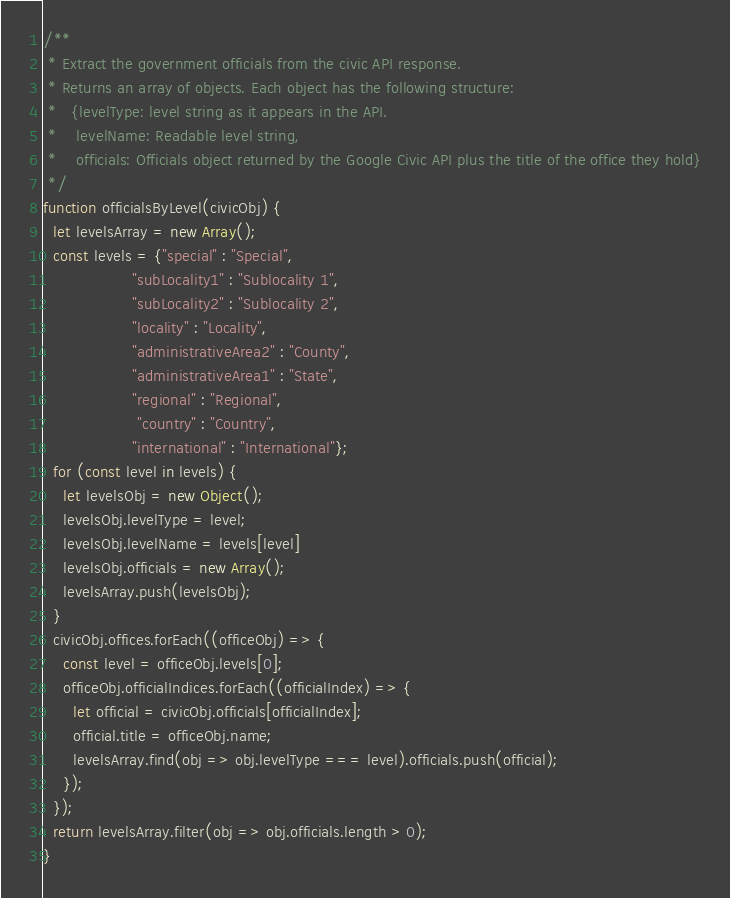Convert code to text. <code><loc_0><loc_0><loc_500><loc_500><_JavaScript_>/**
 * Extract the government officials from the civic API response.
 * Returns an array of objects. Each object has the following structure:
 *   {levelType: level string as it appears in the API.
 *    levelName: Readable level string,
 *    officials: Officials object returned by the Google Civic API plus the title of the office they hold}
 */
function officialsByLevel(civicObj) {
  let levelsArray = new Array();
  const levels = {"special" : "Special",
                  "subLocality1" : "Sublocality 1",
                  "subLocality2" : "Sublocality 2",
                  "locality" : "Locality",
                  "administrativeArea2" : "County",
                  "administrativeArea1" : "State",
                  "regional" : "Regional",
                   "country" : "Country",
                  "international" : "International"};
  for (const level in levels) {
    let levelsObj = new Object();
    levelsObj.levelType = level;
    levelsObj.levelName = levels[level]
    levelsObj.officials = new Array();
    levelsArray.push(levelsObj);
  }
  civicObj.offices.forEach((officeObj) => {
    const level = officeObj.levels[0];
    officeObj.officialIndices.forEach((officialIndex) => {
      let official = civicObj.officials[officialIndex];
      official.title = officeObj.name;
      levelsArray.find(obj => obj.levelType === level).officials.push(official);
    });
  });
  return levelsArray.filter(obj => obj.officials.length > 0);
}
</code> 